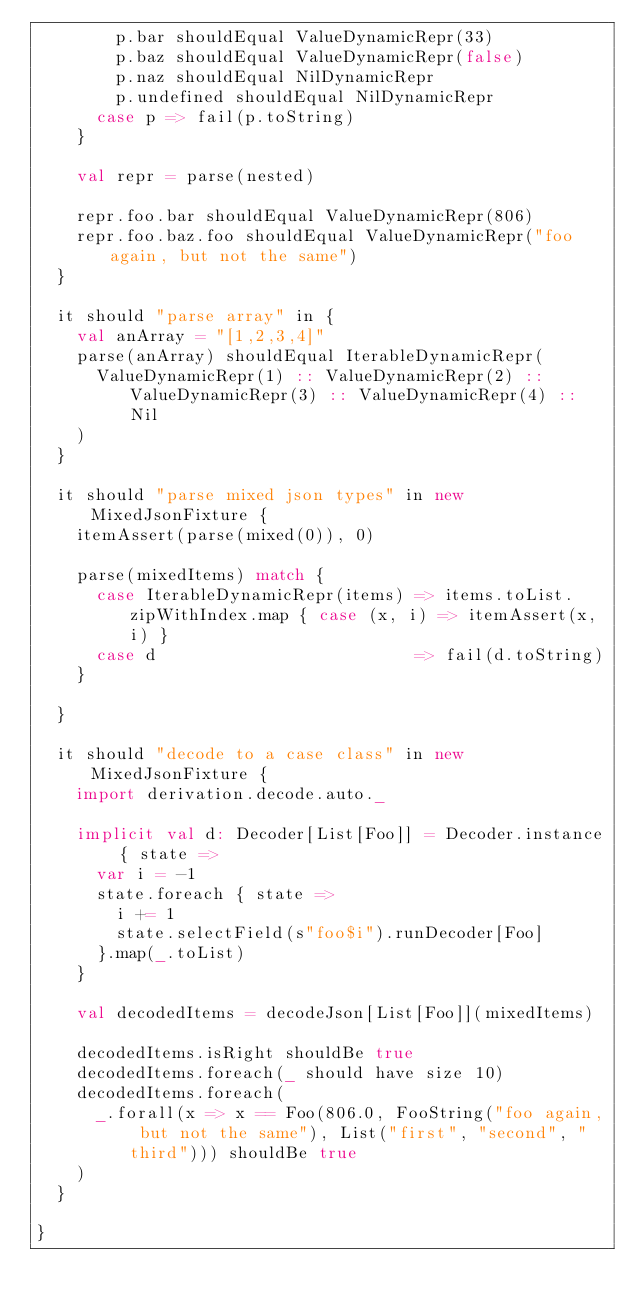Convert code to text. <code><loc_0><loc_0><loc_500><loc_500><_Scala_>        p.bar shouldEqual ValueDynamicRepr(33)
        p.baz shouldEqual ValueDynamicRepr(false)
        p.naz shouldEqual NilDynamicRepr
        p.undefined shouldEqual NilDynamicRepr
      case p => fail(p.toString)
    }

    val repr = parse(nested)

    repr.foo.bar shouldEqual ValueDynamicRepr(806)
    repr.foo.baz.foo shouldEqual ValueDynamicRepr("foo again, but not the same")
  }

  it should "parse array" in {
    val anArray = "[1,2,3,4]"
    parse(anArray) shouldEqual IterableDynamicRepr(
      ValueDynamicRepr(1) :: ValueDynamicRepr(2) :: ValueDynamicRepr(3) :: ValueDynamicRepr(4) :: Nil
    )
  }

  it should "parse mixed json types" in new MixedJsonFixture {
    itemAssert(parse(mixed(0)), 0)

    parse(mixedItems) match {
      case IterableDynamicRepr(items) => items.toList.zipWithIndex.map { case (x, i) => itemAssert(x, i) }
      case d                          => fail(d.toString)
    }

  }

  it should "decode to a case class" in new MixedJsonFixture {
    import derivation.decode.auto._

    implicit val d: Decoder[List[Foo]] = Decoder.instance { state =>
      var i = -1
      state.foreach { state =>
        i += 1
        state.selectField(s"foo$i").runDecoder[Foo]
      }.map(_.toList)
    }

    val decodedItems = decodeJson[List[Foo]](mixedItems)

    decodedItems.isRight shouldBe true
    decodedItems.foreach(_ should have size 10)
    decodedItems.foreach(
      _.forall(x => x == Foo(806.0, FooString("foo again, but not the same"), List("first", "second", "third"))) shouldBe true
    )
  }

}
</code> 